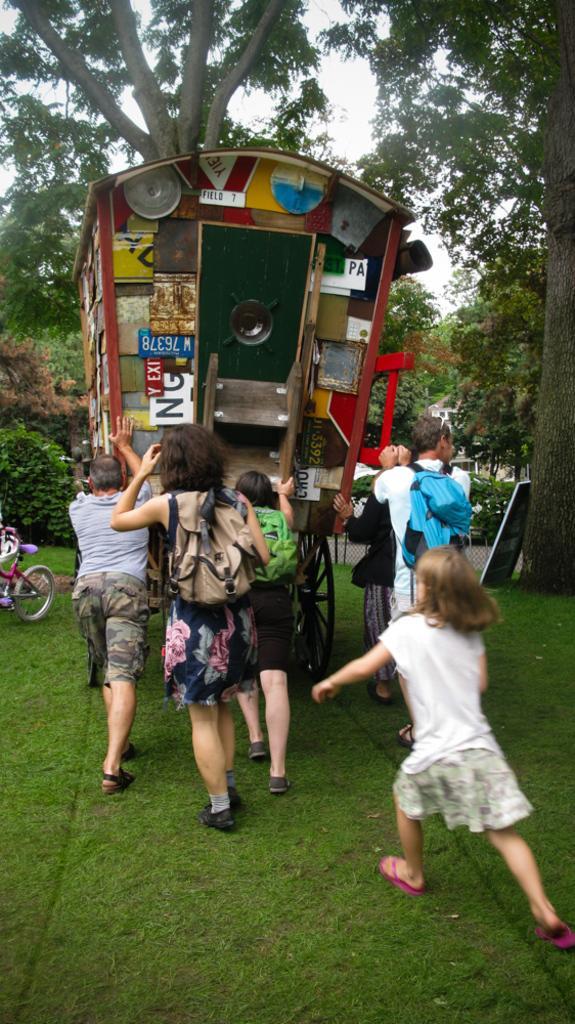Describe this image in one or two sentences. In this picture we can see group of people where they are pushing the vehicle and a girl is running behind them and aside to this vehicle we have bicycle and they all are on the ground with grass and in the background we can see trees, sky, here the persons are carrying their bags. 